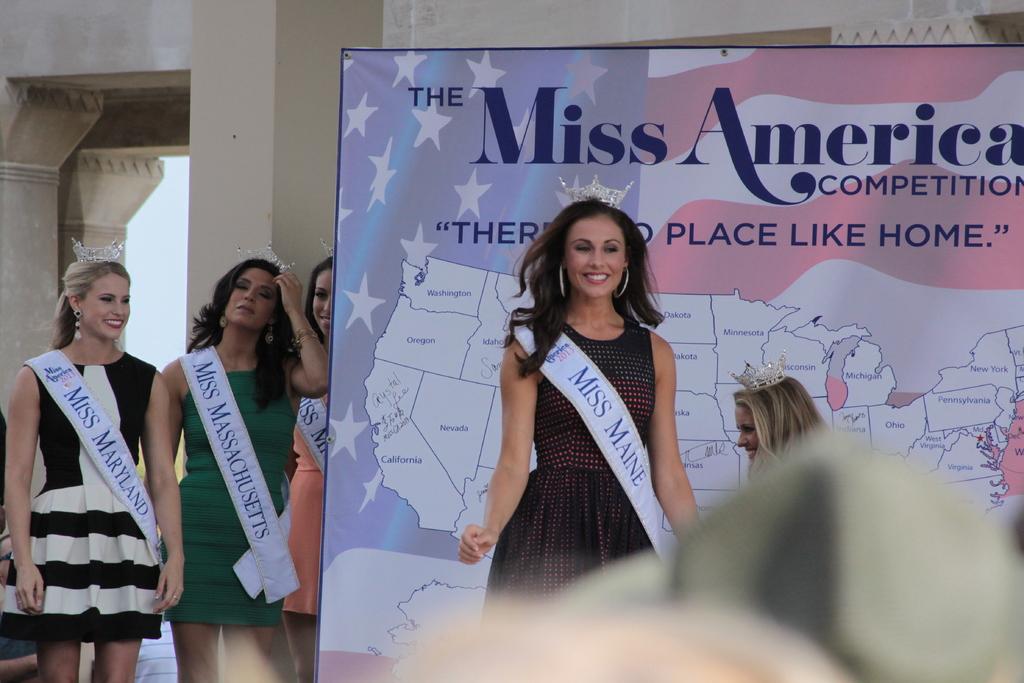What is the contest for?
Offer a very short reply. Miss america. What states are the three girls from?
Ensure brevity in your answer.  Maryland, maine, massachusetts. 